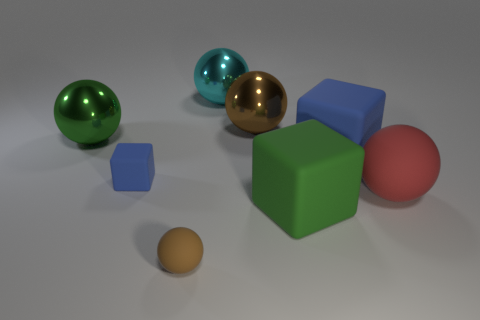How does the composition of objects in the image evoke a sense of balance or imbalance? The image presents a symmetrical arrangement of spherical objects on the left and right which brings a sense of balance. However, the central placement of the larger objects amidst smaller ones also creates an asymmetry which introduces a subtle sense of imbalance to the scene. This dynamic could be interpreted as a visual metaphor for harmony coexisting with unpredictability. 